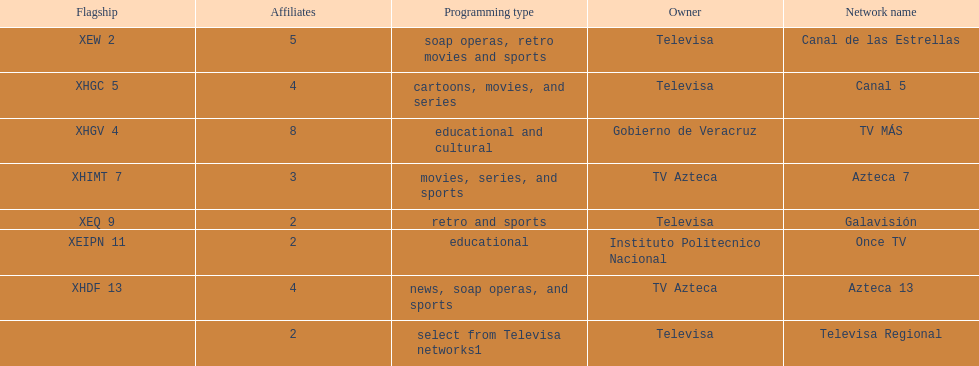Write the full table. {'header': ['Flagship', 'Affiliates', 'Programming type', 'Owner', 'Network name'], 'rows': [['XEW 2', '5', 'soap operas, retro movies and sports', 'Televisa', 'Canal de las Estrellas'], ['XHGC 5', '4', 'cartoons, movies, and series', 'Televisa', 'Canal 5'], ['XHGV 4', '8', 'educational and cultural', 'Gobierno de Veracruz', 'TV MÁS'], ['XHIMT 7', '3', 'movies, series, and sports', 'TV Azteca', 'Azteca 7'], ['XEQ 9', '2', 'retro and sports', 'Televisa', 'Galavisión'], ['XEIPN 11', '2', 'educational', 'Instituto Politecnico Nacional', 'Once TV'], ['XHDF 13', '4', 'news, soap operas, and sports', 'TV Azteca', 'Azteca 13'], ['', '2', 'select from Televisa networks1', 'Televisa', 'Televisa Regional']]} Who has the most number of affiliates? TV MÁS. 